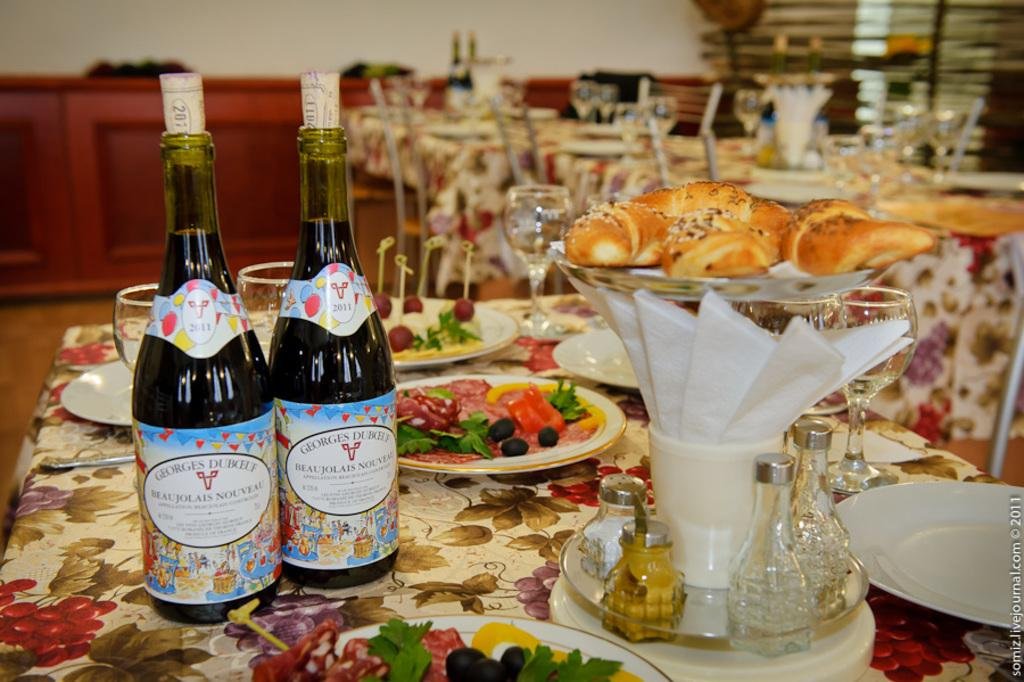How many wine bottles are visible in the image? There are two wine bottles in the image. What else can be seen on the table besides the wine bottles? There are glasses and plates with eatables visible in the image. Where are these objects arranged? The objects are arranged on a table. Can you see any pickles on the table in the image? There is no mention of pickles in the provided facts, so it cannot be determined if any are present in the image. What type of bird can be seen sitting on the wine bottles in the image? There is no bird, such as a crow, present in the image. 